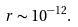Convert formula to latex. <formula><loc_0><loc_0><loc_500><loc_500>r \sim 1 0 ^ { - 1 2 } .</formula> 